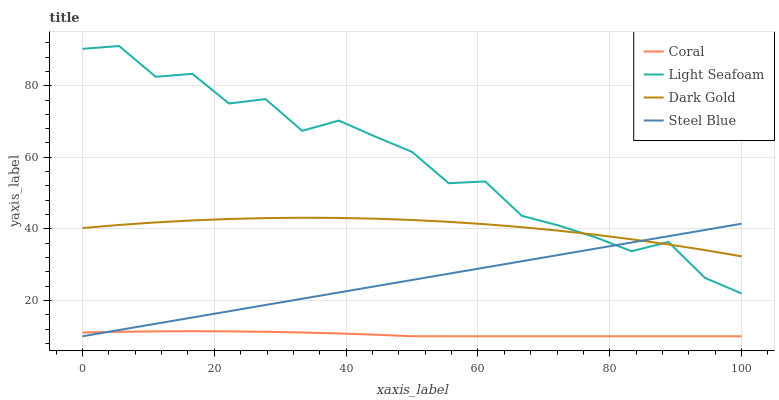Does Coral have the minimum area under the curve?
Answer yes or no. Yes. Does Light Seafoam have the maximum area under the curve?
Answer yes or no. Yes. Does Steel Blue have the minimum area under the curve?
Answer yes or no. No. Does Steel Blue have the maximum area under the curve?
Answer yes or no. No. Is Steel Blue the smoothest?
Answer yes or no. Yes. Is Light Seafoam the roughest?
Answer yes or no. Yes. Is Light Seafoam the smoothest?
Answer yes or no. No. Is Steel Blue the roughest?
Answer yes or no. No. Does Coral have the lowest value?
Answer yes or no. Yes. Does Light Seafoam have the lowest value?
Answer yes or no. No. Does Light Seafoam have the highest value?
Answer yes or no. Yes. Does Steel Blue have the highest value?
Answer yes or no. No. Is Coral less than Dark Gold?
Answer yes or no. Yes. Is Light Seafoam greater than Coral?
Answer yes or no. Yes. Does Light Seafoam intersect Steel Blue?
Answer yes or no. Yes. Is Light Seafoam less than Steel Blue?
Answer yes or no. No. Is Light Seafoam greater than Steel Blue?
Answer yes or no. No. Does Coral intersect Dark Gold?
Answer yes or no. No. 